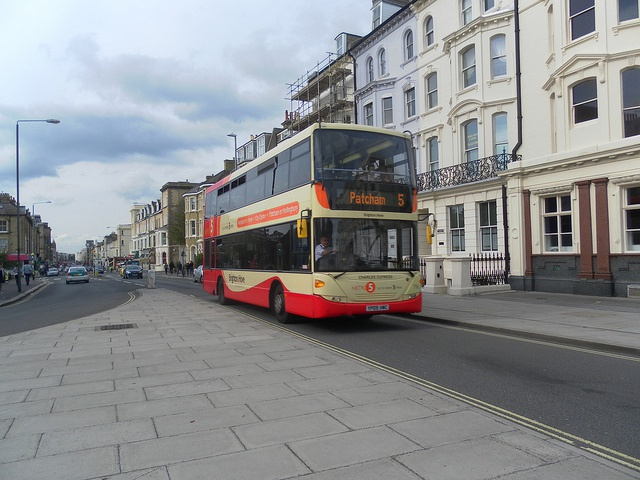Describe the objects in this image and their specific colors. I can see bus in white, black, gray, and darkgray tones, people in white, black, and gray tones, car in white, gray, teal, and black tones, car in white, black, gray, and navy tones, and people in white, gray, and black tones in this image. 